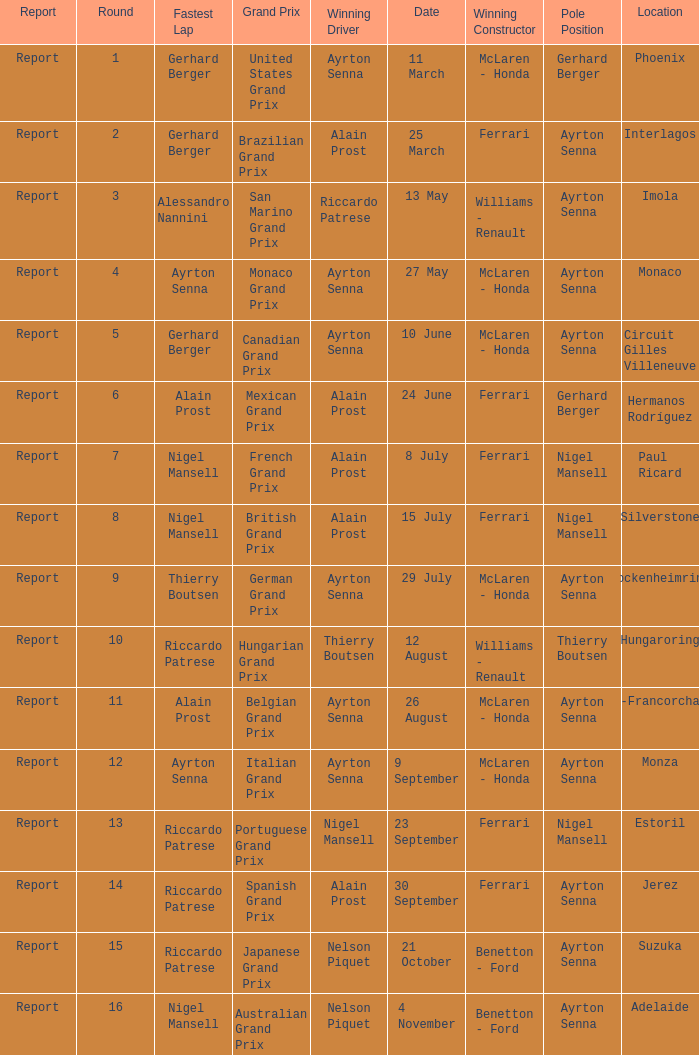What is the Pole Position for the German Grand Prix Ayrton Senna. 